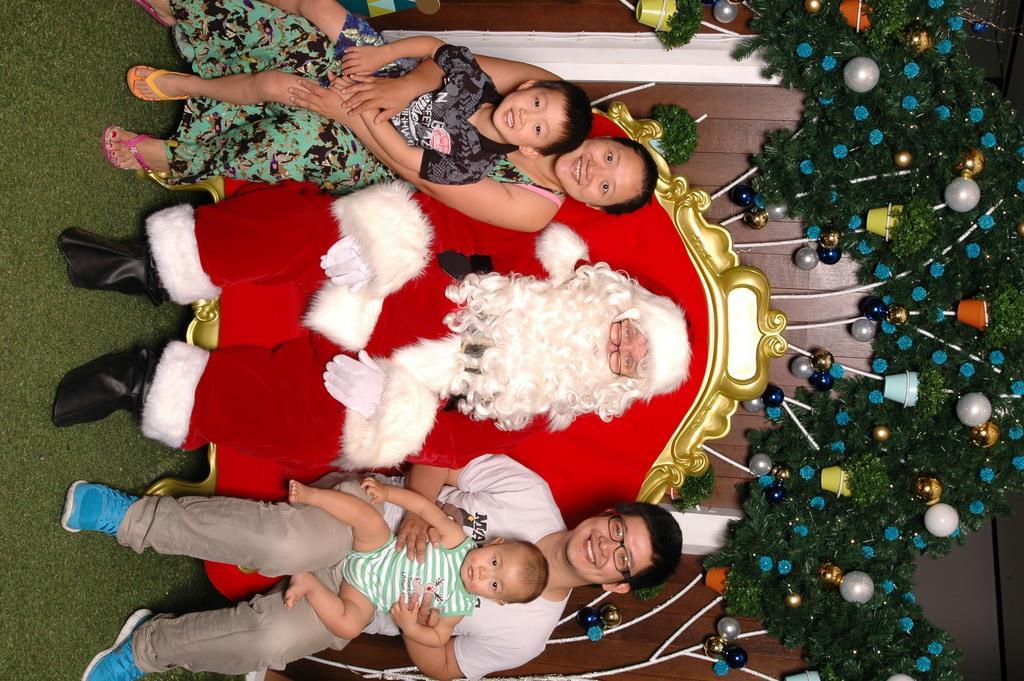Could you give a brief overview of what you see in this image? In the middle of the image, we can see people are sitting on the red chair. Here a man and woman are holding kids. On the left side of the image, we can see grass. On the right side of the image, we can see decorative objects and wooden wall. 